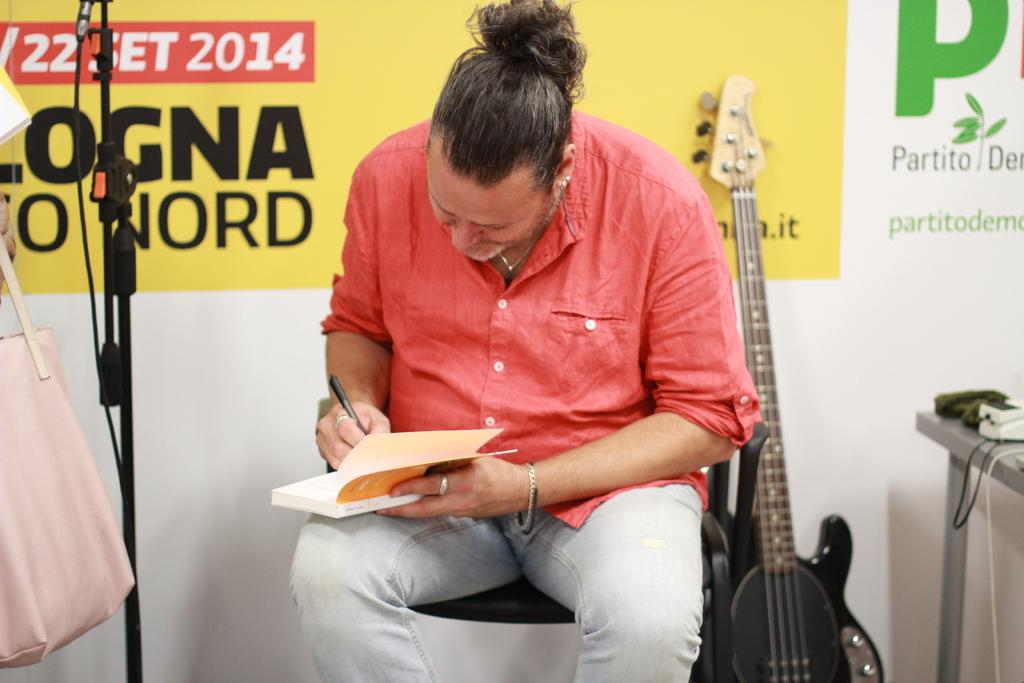<image>
Relay a brief, clear account of the picture shown. Man signing a book in front of the wall that has green lettering Partito 